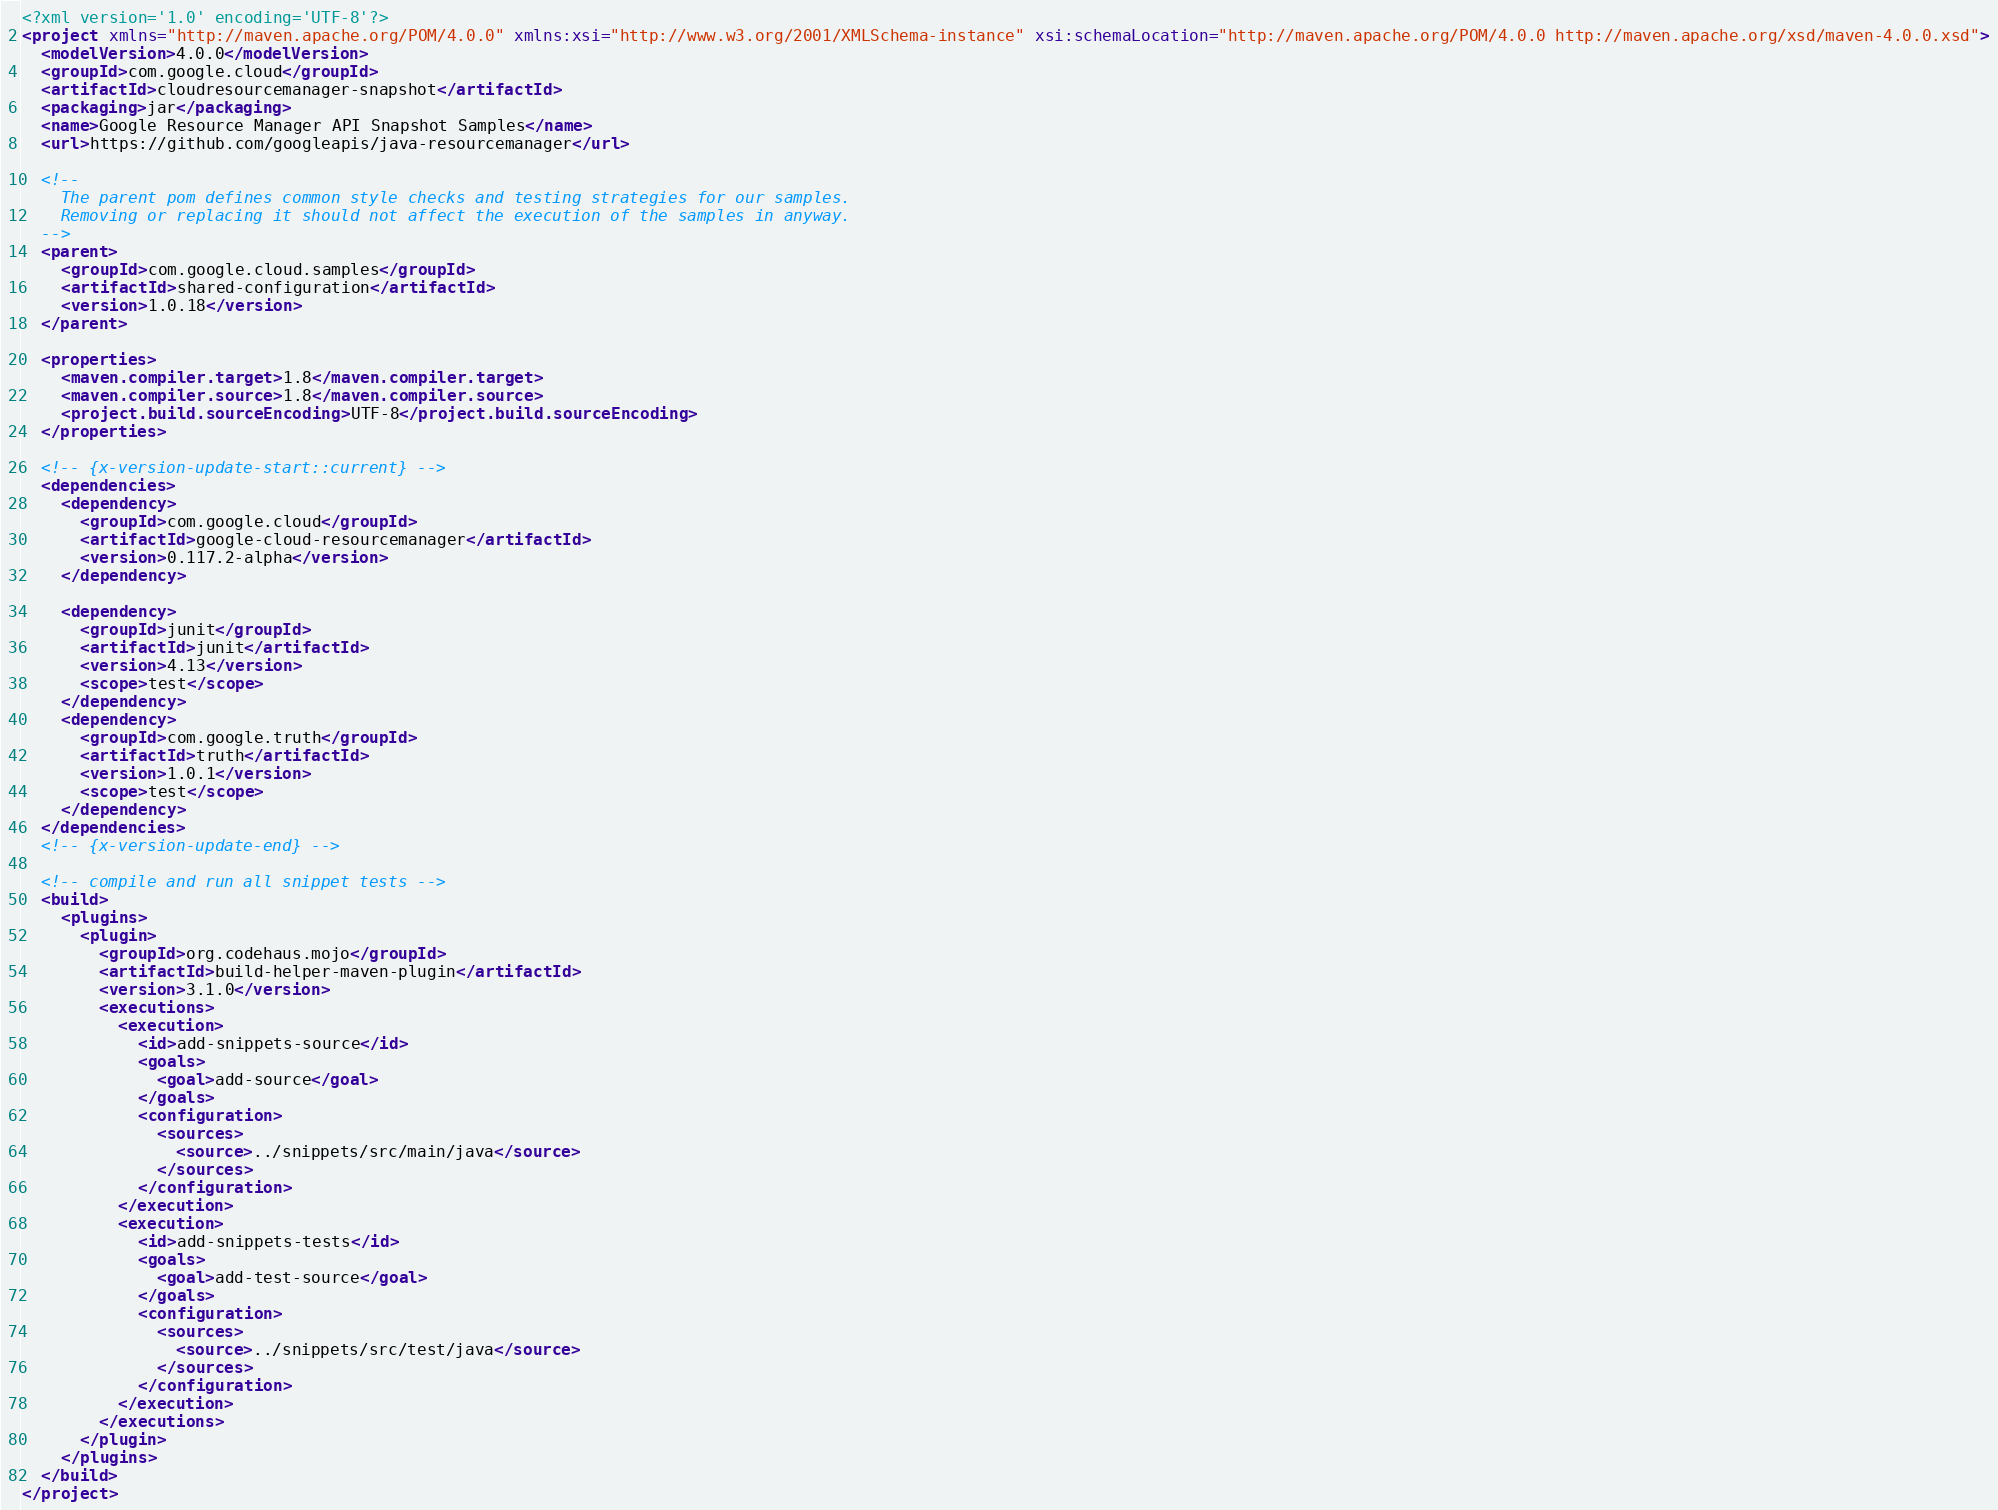<code> <loc_0><loc_0><loc_500><loc_500><_XML_><?xml version='1.0' encoding='UTF-8'?>
<project xmlns="http://maven.apache.org/POM/4.0.0" xmlns:xsi="http://www.w3.org/2001/XMLSchema-instance" xsi:schemaLocation="http://maven.apache.org/POM/4.0.0 http://maven.apache.org/xsd/maven-4.0.0.xsd">
  <modelVersion>4.0.0</modelVersion>
  <groupId>com.google.cloud</groupId>
  <artifactId>cloudresourcemanager-snapshot</artifactId>
  <packaging>jar</packaging>
  <name>Google Resource Manager API Snapshot Samples</name>
  <url>https://github.com/googleapis/java-resourcemanager</url>

  <!--
    The parent pom defines common style checks and testing strategies for our samples.
    Removing or replacing it should not affect the execution of the samples in anyway.
  -->
  <parent>
    <groupId>com.google.cloud.samples</groupId>
    <artifactId>shared-configuration</artifactId>
    <version>1.0.18</version>
  </parent>

  <properties>
    <maven.compiler.target>1.8</maven.compiler.target>
    <maven.compiler.source>1.8</maven.compiler.source>
    <project.build.sourceEncoding>UTF-8</project.build.sourceEncoding>
  </properties>

  <!-- {x-version-update-start::current} -->
  <dependencies>
    <dependency>
      <groupId>com.google.cloud</groupId>
      <artifactId>google-cloud-resourcemanager</artifactId>
      <version>0.117.2-alpha</version>
    </dependency>

    <dependency>
      <groupId>junit</groupId>
      <artifactId>junit</artifactId>
      <version>4.13</version>
      <scope>test</scope>
    </dependency>
    <dependency>
      <groupId>com.google.truth</groupId>
      <artifactId>truth</artifactId>
      <version>1.0.1</version>
      <scope>test</scope>
    </dependency>
  </dependencies>
  <!-- {x-version-update-end} -->

  <!-- compile and run all snippet tests -->
  <build>
    <plugins>
      <plugin>
        <groupId>org.codehaus.mojo</groupId>
        <artifactId>build-helper-maven-plugin</artifactId>
        <version>3.1.0</version>
        <executions>
          <execution>
            <id>add-snippets-source</id>
            <goals>
              <goal>add-source</goal>
            </goals>
            <configuration>
              <sources>
                <source>../snippets/src/main/java</source>
              </sources>
            </configuration>
          </execution>
          <execution>
            <id>add-snippets-tests</id>
            <goals>
              <goal>add-test-source</goal>
            </goals>
            <configuration>
              <sources>
                <source>../snippets/src/test/java</source>
              </sources>
            </configuration>
          </execution>
        </executions>
      </plugin>
    </plugins>
  </build>
</project></code> 